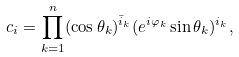Convert formula to latex. <formula><loc_0><loc_0><loc_500><loc_500>c _ { i } = \prod _ { k = 1 } ^ { n } ( \cos \theta _ { k } ) ^ { \bar { i } _ { k } } ( e ^ { i \varphi _ { k } } \sin \theta _ { k } ) ^ { i _ { k } } ,</formula> 